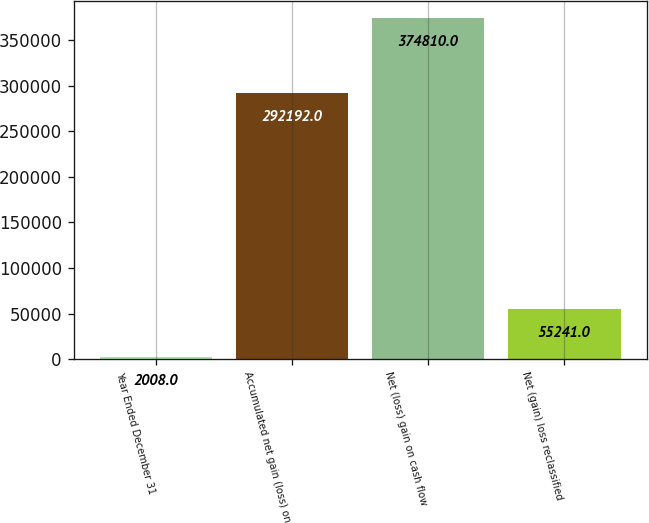Convert chart to OTSL. <chart><loc_0><loc_0><loc_500><loc_500><bar_chart><fcel>Year Ended December 31<fcel>Accumulated net gain (loss) on<fcel>Net (loss) gain on cash flow<fcel>Net (gain) loss reclassified<nl><fcel>2008<fcel>292192<fcel>374810<fcel>55241<nl></chart> 